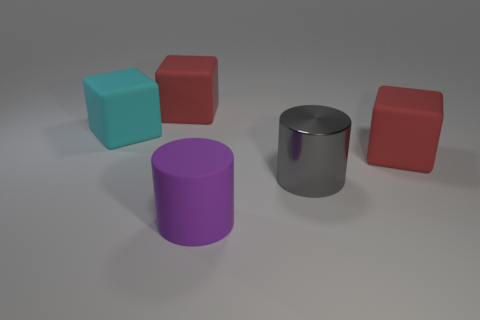Subtract 1 blocks. How many blocks are left? 2 Add 3 big green balls. How many objects exist? 8 Subtract all cylinders. How many objects are left? 3 Subtract 0 blue balls. How many objects are left? 5 Subtract all purple matte things. Subtract all big cyan things. How many objects are left? 3 Add 3 big red cubes. How many big red cubes are left? 5 Add 3 blocks. How many blocks exist? 6 